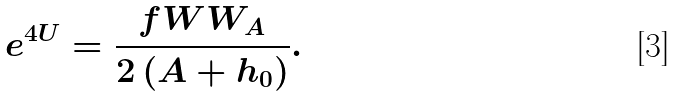<formula> <loc_0><loc_0><loc_500><loc_500>e ^ { 4 U } = \frac { f W W _ { A } } { 2 \left ( A + h _ { 0 } \right ) } .</formula> 